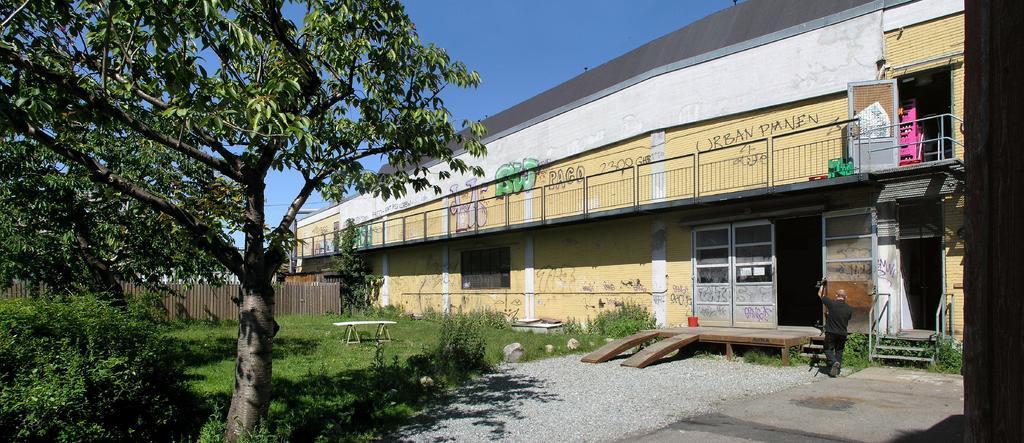Could you give a brief overview of what you see in this image? In this picture we can see a building, one person holding an object, side we can see trees, plants and grass. 